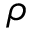Convert formula to latex. <formula><loc_0><loc_0><loc_500><loc_500>\rho</formula> 